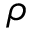Convert formula to latex. <formula><loc_0><loc_0><loc_500><loc_500>\rho</formula> 